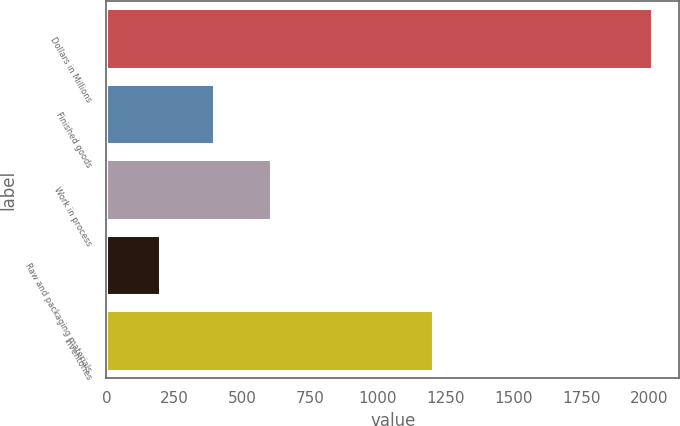Convert chart to OTSL. <chart><loc_0><loc_0><loc_500><loc_500><bar_chart><fcel>Dollars in Millions<fcel>Finished goods<fcel>Work in process<fcel>Raw and packaging materials<fcel>Inventories<nl><fcel>2010<fcel>397<fcel>608<fcel>199<fcel>1204<nl></chart> 